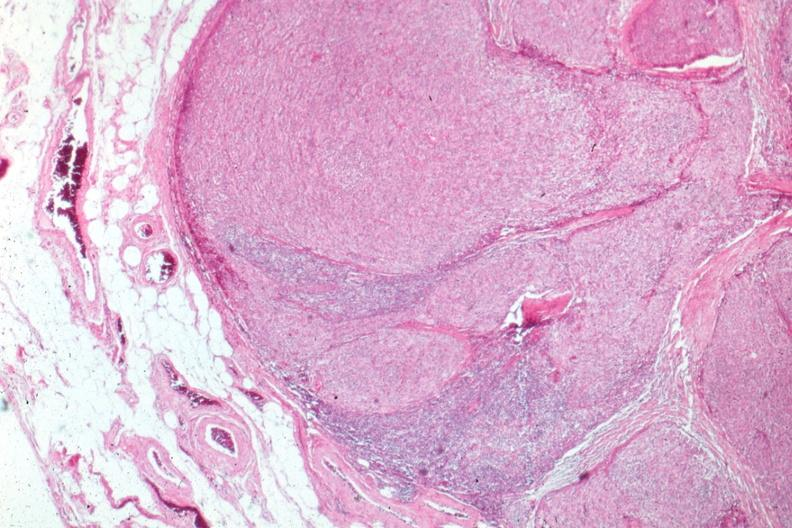does this image show surgical specimen?
Answer the question using a single word or phrase. Yes 